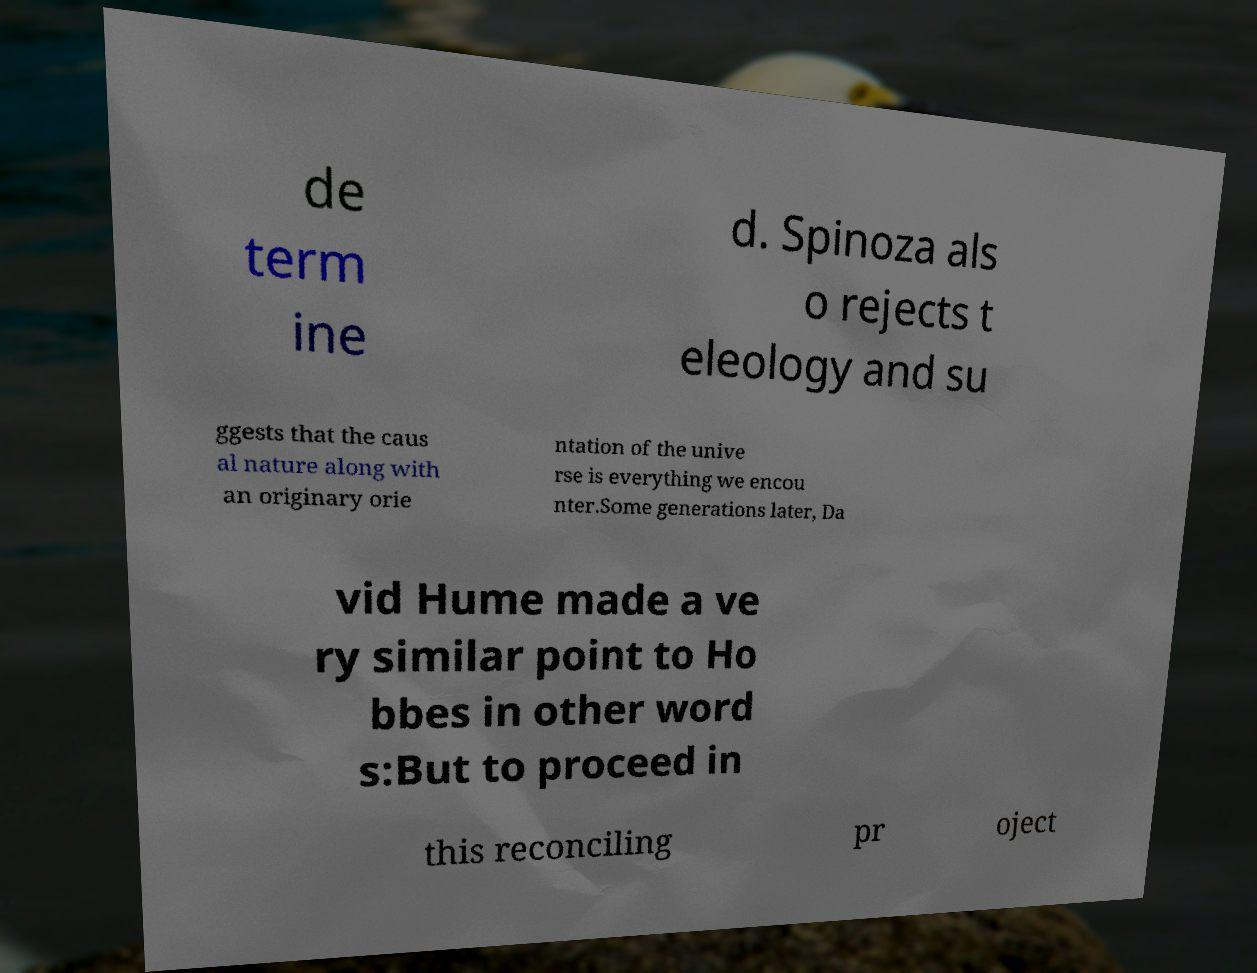Please read and relay the text visible in this image. What does it say? de term ine d. Spinoza als o rejects t eleology and su ggests that the caus al nature along with an originary orie ntation of the unive rse is everything we encou nter.Some generations later, Da vid Hume made a ve ry similar point to Ho bbes in other word s:But to proceed in this reconciling pr oject 